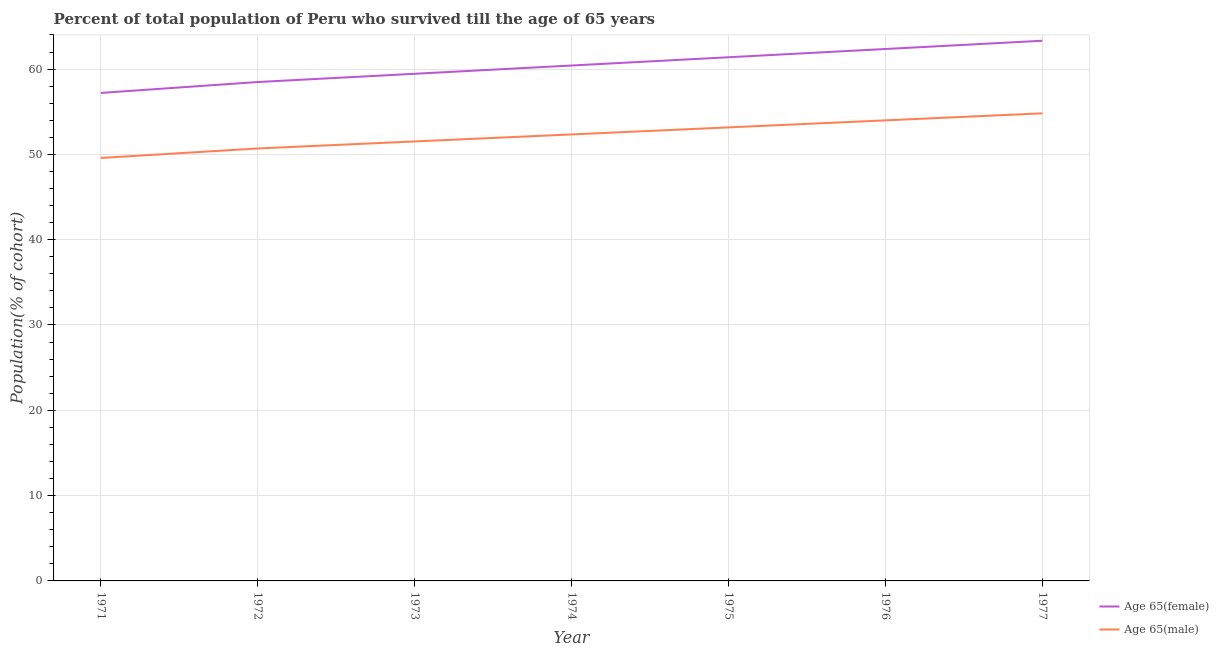What is the percentage of female population who survived till age of 65 in 1974?
Provide a succinct answer. 60.42. Across all years, what is the maximum percentage of male population who survived till age of 65?
Make the answer very short. 54.81. Across all years, what is the minimum percentage of female population who survived till age of 65?
Ensure brevity in your answer.  57.2. In which year was the percentage of male population who survived till age of 65 maximum?
Give a very brief answer. 1977. In which year was the percentage of male population who survived till age of 65 minimum?
Your answer should be very brief. 1971. What is the total percentage of male population who survived till age of 65 in the graph?
Provide a short and direct response. 366.09. What is the difference between the percentage of male population who survived till age of 65 in 1972 and that in 1975?
Ensure brevity in your answer.  -2.47. What is the difference between the percentage of female population who survived till age of 65 in 1976 and the percentage of male population who survived till age of 65 in 1972?
Provide a succinct answer. 11.66. What is the average percentage of female population who survived till age of 65 per year?
Provide a short and direct response. 60.37. In the year 1974, what is the difference between the percentage of female population who survived till age of 65 and percentage of male population who survived till age of 65?
Give a very brief answer. 8.08. What is the ratio of the percentage of male population who survived till age of 65 in 1973 to that in 1976?
Your answer should be compact. 0.95. Is the percentage of male population who survived till age of 65 in 1975 less than that in 1977?
Your response must be concise. Yes. What is the difference between the highest and the second highest percentage of male population who survived till age of 65?
Offer a terse response. 0.82. What is the difference between the highest and the lowest percentage of female population who survived till age of 65?
Keep it short and to the point. 6.12. Is the sum of the percentage of male population who survived till age of 65 in 1975 and 1977 greater than the maximum percentage of female population who survived till age of 65 across all years?
Keep it short and to the point. Yes. Does the percentage of female population who survived till age of 65 monotonically increase over the years?
Give a very brief answer. Yes. What is the difference between two consecutive major ticks on the Y-axis?
Make the answer very short. 10. Are the values on the major ticks of Y-axis written in scientific E-notation?
Offer a terse response. No. Does the graph contain grids?
Keep it short and to the point. Yes. Where does the legend appear in the graph?
Your answer should be very brief. Bottom right. What is the title of the graph?
Keep it short and to the point. Percent of total population of Peru who survived till the age of 65 years. What is the label or title of the X-axis?
Offer a very short reply. Year. What is the label or title of the Y-axis?
Your answer should be very brief. Population(% of cohort). What is the Population(% of cohort) in Age 65(female) in 1971?
Your answer should be compact. 57.2. What is the Population(% of cohort) of Age 65(male) in 1971?
Give a very brief answer. 49.58. What is the Population(% of cohort) of Age 65(female) in 1972?
Your answer should be compact. 58.48. What is the Population(% of cohort) of Age 65(male) in 1972?
Offer a terse response. 50.69. What is the Population(% of cohort) of Age 65(female) in 1973?
Offer a very short reply. 59.45. What is the Population(% of cohort) of Age 65(male) in 1973?
Keep it short and to the point. 51.52. What is the Population(% of cohort) of Age 65(female) in 1974?
Offer a terse response. 60.42. What is the Population(% of cohort) of Age 65(male) in 1974?
Offer a very short reply. 52.34. What is the Population(% of cohort) of Age 65(female) in 1975?
Keep it short and to the point. 61.38. What is the Population(% of cohort) of Age 65(male) in 1975?
Provide a succinct answer. 53.16. What is the Population(% of cohort) in Age 65(female) in 1976?
Offer a terse response. 62.35. What is the Population(% of cohort) in Age 65(male) in 1976?
Your response must be concise. 53.99. What is the Population(% of cohort) of Age 65(female) in 1977?
Keep it short and to the point. 63.32. What is the Population(% of cohort) in Age 65(male) in 1977?
Your answer should be very brief. 54.81. Across all years, what is the maximum Population(% of cohort) in Age 65(female)?
Make the answer very short. 63.32. Across all years, what is the maximum Population(% of cohort) of Age 65(male)?
Provide a short and direct response. 54.81. Across all years, what is the minimum Population(% of cohort) of Age 65(female)?
Offer a very short reply. 57.2. Across all years, what is the minimum Population(% of cohort) in Age 65(male)?
Your answer should be very brief. 49.58. What is the total Population(% of cohort) in Age 65(female) in the graph?
Your answer should be compact. 422.6. What is the total Population(% of cohort) of Age 65(male) in the graph?
Make the answer very short. 366.09. What is the difference between the Population(% of cohort) in Age 65(female) in 1971 and that in 1972?
Your answer should be compact. -1.28. What is the difference between the Population(% of cohort) in Age 65(male) in 1971 and that in 1972?
Give a very brief answer. -1.11. What is the difference between the Population(% of cohort) of Age 65(female) in 1971 and that in 1973?
Keep it short and to the point. -2.25. What is the difference between the Population(% of cohort) in Age 65(male) in 1971 and that in 1973?
Keep it short and to the point. -1.94. What is the difference between the Population(% of cohort) of Age 65(female) in 1971 and that in 1974?
Your answer should be compact. -3.21. What is the difference between the Population(% of cohort) in Age 65(male) in 1971 and that in 1974?
Your answer should be compact. -2.76. What is the difference between the Population(% of cohort) in Age 65(female) in 1971 and that in 1975?
Ensure brevity in your answer.  -4.18. What is the difference between the Population(% of cohort) of Age 65(male) in 1971 and that in 1975?
Keep it short and to the point. -3.58. What is the difference between the Population(% of cohort) of Age 65(female) in 1971 and that in 1976?
Your answer should be compact. -5.15. What is the difference between the Population(% of cohort) of Age 65(male) in 1971 and that in 1976?
Your answer should be very brief. -4.41. What is the difference between the Population(% of cohort) in Age 65(female) in 1971 and that in 1977?
Ensure brevity in your answer.  -6.12. What is the difference between the Population(% of cohort) of Age 65(male) in 1971 and that in 1977?
Ensure brevity in your answer.  -5.23. What is the difference between the Population(% of cohort) in Age 65(female) in 1972 and that in 1973?
Provide a short and direct response. -0.97. What is the difference between the Population(% of cohort) of Age 65(male) in 1972 and that in 1973?
Give a very brief answer. -0.82. What is the difference between the Population(% of cohort) in Age 65(female) in 1972 and that in 1974?
Make the answer very short. -1.94. What is the difference between the Population(% of cohort) of Age 65(male) in 1972 and that in 1974?
Provide a succinct answer. -1.65. What is the difference between the Population(% of cohort) of Age 65(female) in 1972 and that in 1975?
Ensure brevity in your answer.  -2.9. What is the difference between the Population(% of cohort) in Age 65(male) in 1972 and that in 1975?
Your answer should be very brief. -2.47. What is the difference between the Population(% of cohort) of Age 65(female) in 1972 and that in 1976?
Offer a terse response. -3.87. What is the difference between the Population(% of cohort) of Age 65(male) in 1972 and that in 1976?
Offer a very short reply. -3.3. What is the difference between the Population(% of cohort) in Age 65(female) in 1972 and that in 1977?
Your answer should be compact. -4.84. What is the difference between the Population(% of cohort) of Age 65(male) in 1972 and that in 1977?
Your response must be concise. -4.12. What is the difference between the Population(% of cohort) of Age 65(female) in 1973 and that in 1974?
Ensure brevity in your answer.  -0.97. What is the difference between the Population(% of cohort) in Age 65(male) in 1973 and that in 1974?
Your answer should be compact. -0.82. What is the difference between the Population(% of cohort) in Age 65(female) in 1973 and that in 1975?
Your answer should be compact. -1.94. What is the difference between the Population(% of cohort) of Age 65(male) in 1973 and that in 1975?
Your answer should be very brief. -1.65. What is the difference between the Population(% of cohort) in Age 65(female) in 1973 and that in 1976?
Keep it short and to the point. -2.9. What is the difference between the Population(% of cohort) in Age 65(male) in 1973 and that in 1976?
Make the answer very short. -2.47. What is the difference between the Population(% of cohort) in Age 65(female) in 1973 and that in 1977?
Provide a succinct answer. -3.87. What is the difference between the Population(% of cohort) in Age 65(male) in 1973 and that in 1977?
Keep it short and to the point. -3.3. What is the difference between the Population(% of cohort) in Age 65(female) in 1974 and that in 1975?
Your answer should be very brief. -0.97. What is the difference between the Population(% of cohort) in Age 65(male) in 1974 and that in 1975?
Your answer should be compact. -0.82. What is the difference between the Population(% of cohort) in Age 65(female) in 1974 and that in 1976?
Your response must be concise. -1.94. What is the difference between the Population(% of cohort) in Age 65(male) in 1974 and that in 1976?
Make the answer very short. -1.65. What is the difference between the Population(% of cohort) of Age 65(female) in 1974 and that in 1977?
Provide a succinct answer. -2.9. What is the difference between the Population(% of cohort) of Age 65(male) in 1974 and that in 1977?
Make the answer very short. -2.47. What is the difference between the Population(% of cohort) of Age 65(female) in 1975 and that in 1976?
Offer a terse response. -0.97. What is the difference between the Population(% of cohort) in Age 65(male) in 1975 and that in 1976?
Keep it short and to the point. -0.82. What is the difference between the Population(% of cohort) of Age 65(female) in 1975 and that in 1977?
Your answer should be very brief. -1.94. What is the difference between the Population(% of cohort) in Age 65(male) in 1975 and that in 1977?
Your response must be concise. -1.65. What is the difference between the Population(% of cohort) of Age 65(female) in 1976 and that in 1977?
Offer a terse response. -0.97. What is the difference between the Population(% of cohort) of Age 65(male) in 1976 and that in 1977?
Offer a very short reply. -0.82. What is the difference between the Population(% of cohort) of Age 65(female) in 1971 and the Population(% of cohort) of Age 65(male) in 1972?
Provide a succinct answer. 6.51. What is the difference between the Population(% of cohort) of Age 65(female) in 1971 and the Population(% of cohort) of Age 65(male) in 1973?
Ensure brevity in your answer.  5.69. What is the difference between the Population(% of cohort) of Age 65(female) in 1971 and the Population(% of cohort) of Age 65(male) in 1974?
Offer a very short reply. 4.86. What is the difference between the Population(% of cohort) in Age 65(female) in 1971 and the Population(% of cohort) in Age 65(male) in 1975?
Offer a very short reply. 4.04. What is the difference between the Population(% of cohort) in Age 65(female) in 1971 and the Population(% of cohort) in Age 65(male) in 1976?
Keep it short and to the point. 3.22. What is the difference between the Population(% of cohort) in Age 65(female) in 1971 and the Population(% of cohort) in Age 65(male) in 1977?
Provide a short and direct response. 2.39. What is the difference between the Population(% of cohort) of Age 65(female) in 1972 and the Population(% of cohort) of Age 65(male) in 1973?
Provide a succinct answer. 6.96. What is the difference between the Population(% of cohort) in Age 65(female) in 1972 and the Population(% of cohort) in Age 65(male) in 1974?
Provide a succinct answer. 6.14. What is the difference between the Population(% of cohort) in Age 65(female) in 1972 and the Population(% of cohort) in Age 65(male) in 1975?
Make the answer very short. 5.32. What is the difference between the Population(% of cohort) of Age 65(female) in 1972 and the Population(% of cohort) of Age 65(male) in 1976?
Offer a terse response. 4.49. What is the difference between the Population(% of cohort) of Age 65(female) in 1972 and the Population(% of cohort) of Age 65(male) in 1977?
Offer a very short reply. 3.67. What is the difference between the Population(% of cohort) in Age 65(female) in 1973 and the Population(% of cohort) in Age 65(male) in 1974?
Your response must be concise. 7.11. What is the difference between the Population(% of cohort) in Age 65(female) in 1973 and the Population(% of cohort) in Age 65(male) in 1975?
Keep it short and to the point. 6.28. What is the difference between the Population(% of cohort) of Age 65(female) in 1973 and the Population(% of cohort) of Age 65(male) in 1976?
Provide a short and direct response. 5.46. What is the difference between the Population(% of cohort) of Age 65(female) in 1973 and the Population(% of cohort) of Age 65(male) in 1977?
Provide a short and direct response. 4.64. What is the difference between the Population(% of cohort) in Age 65(female) in 1974 and the Population(% of cohort) in Age 65(male) in 1975?
Provide a succinct answer. 7.25. What is the difference between the Population(% of cohort) of Age 65(female) in 1974 and the Population(% of cohort) of Age 65(male) in 1976?
Ensure brevity in your answer.  6.43. What is the difference between the Population(% of cohort) in Age 65(female) in 1974 and the Population(% of cohort) in Age 65(male) in 1977?
Make the answer very short. 5.6. What is the difference between the Population(% of cohort) of Age 65(female) in 1975 and the Population(% of cohort) of Age 65(male) in 1976?
Offer a very short reply. 7.4. What is the difference between the Population(% of cohort) in Age 65(female) in 1975 and the Population(% of cohort) in Age 65(male) in 1977?
Offer a very short reply. 6.57. What is the difference between the Population(% of cohort) of Age 65(female) in 1976 and the Population(% of cohort) of Age 65(male) in 1977?
Ensure brevity in your answer.  7.54. What is the average Population(% of cohort) in Age 65(female) per year?
Your response must be concise. 60.37. What is the average Population(% of cohort) of Age 65(male) per year?
Ensure brevity in your answer.  52.3. In the year 1971, what is the difference between the Population(% of cohort) of Age 65(female) and Population(% of cohort) of Age 65(male)?
Your answer should be very brief. 7.62. In the year 1972, what is the difference between the Population(% of cohort) in Age 65(female) and Population(% of cohort) in Age 65(male)?
Your response must be concise. 7.79. In the year 1973, what is the difference between the Population(% of cohort) in Age 65(female) and Population(% of cohort) in Age 65(male)?
Provide a short and direct response. 7.93. In the year 1974, what is the difference between the Population(% of cohort) of Age 65(female) and Population(% of cohort) of Age 65(male)?
Offer a terse response. 8.08. In the year 1975, what is the difference between the Population(% of cohort) in Age 65(female) and Population(% of cohort) in Age 65(male)?
Your answer should be compact. 8.22. In the year 1976, what is the difference between the Population(% of cohort) of Age 65(female) and Population(% of cohort) of Age 65(male)?
Provide a short and direct response. 8.37. In the year 1977, what is the difference between the Population(% of cohort) in Age 65(female) and Population(% of cohort) in Age 65(male)?
Your answer should be very brief. 8.51. What is the ratio of the Population(% of cohort) in Age 65(female) in 1971 to that in 1972?
Your response must be concise. 0.98. What is the ratio of the Population(% of cohort) of Age 65(male) in 1971 to that in 1972?
Your response must be concise. 0.98. What is the ratio of the Population(% of cohort) in Age 65(female) in 1971 to that in 1973?
Offer a very short reply. 0.96. What is the ratio of the Population(% of cohort) in Age 65(male) in 1971 to that in 1973?
Keep it short and to the point. 0.96. What is the ratio of the Population(% of cohort) in Age 65(female) in 1971 to that in 1974?
Make the answer very short. 0.95. What is the ratio of the Population(% of cohort) of Age 65(male) in 1971 to that in 1974?
Your response must be concise. 0.95. What is the ratio of the Population(% of cohort) of Age 65(female) in 1971 to that in 1975?
Give a very brief answer. 0.93. What is the ratio of the Population(% of cohort) in Age 65(male) in 1971 to that in 1975?
Provide a succinct answer. 0.93. What is the ratio of the Population(% of cohort) in Age 65(female) in 1971 to that in 1976?
Your answer should be compact. 0.92. What is the ratio of the Population(% of cohort) of Age 65(male) in 1971 to that in 1976?
Your answer should be very brief. 0.92. What is the ratio of the Population(% of cohort) of Age 65(female) in 1971 to that in 1977?
Make the answer very short. 0.9. What is the ratio of the Population(% of cohort) in Age 65(male) in 1971 to that in 1977?
Your answer should be compact. 0.9. What is the ratio of the Population(% of cohort) of Age 65(female) in 1972 to that in 1973?
Your answer should be compact. 0.98. What is the ratio of the Population(% of cohort) of Age 65(female) in 1972 to that in 1974?
Your answer should be compact. 0.97. What is the ratio of the Population(% of cohort) of Age 65(male) in 1972 to that in 1974?
Offer a terse response. 0.97. What is the ratio of the Population(% of cohort) in Age 65(female) in 1972 to that in 1975?
Your response must be concise. 0.95. What is the ratio of the Population(% of cohort) of Age 65(male) in 1972 to that in 1975?
Your answer should be compact. 0.95. What is the ratio of the Population(% of cohort) of Age 65(female) in 1972 to that in 1976?
Give a very brief answer. 0.94. What is the ratio of the Population(% of cohort) in Age 65(male) in 1972 to that in 1976?
Give a very brief answer. 0.94. What is the ratio of the Population(% of cohort) of Age 65(female) in 1972 to that in 1977?
Offer a terse response. 0.92. What is the ratio of the Population(% of cohort) in Age 65(male) in 1972 to that in 1977?
Your answer should be compact. 0.92. What is the ratio of the Population(% of cohort) in Age 65(female) in 1973 to that in 1974?
Your answer should be compact. 0.98. What is the ratio of the Population(% of cohort) in Age 65(male) in 1973 to that in 1974?
Keep it short and to the point. 0.98. What is the ratio of the Population(% of cohort) in Age 65(female) in 1973 to that in 1975?
Ensure brevity in your answer.  0.97. What is the ratio of the Population(% of cohort) of Age 65(male) in 1973 to that in 1975?
Offer a terse response. 0.97. What is the ratio of the Population(% of cohort) in Age 65(female) in 1973 to that in 1976?
Give a very brief answer. 0.95. What is the ratio of the Population(% of cohort) of Age 65(male) in 1973 to that in 1976?
Offer a very short reply. 0.95. What is the ratio of the Population(% of cohort) of Age 65(female) in 1973 to that in 1977?
Offer a terse response. 0.94. What is the ratio of the Population(% of cohort) of Age 65(male) in 1973 to that in 1977?
Your answer should be very brief. 0.94. What is the ratio of the Population(% of cohort) of Age 65(female) in 1974 to that in 1975?
Keep it short and to the point. 0.98. What is the ratio of the Population(% of cohort) in Age 65(male) in 1974 to that in 1975?
Give a very brief answer. 0.98. What is the ratio of the Population(% of cohort) of Age 65(female) in 1974 to that in 1976?
Offer a terse response. 0.97. What is the ratio of the Population(% of cohort) of Age 65(male) in 1974 to that in 1976?
Provide a short and direct response. 0.97. What is the ratio of the Population(% of cohort) in Age 65(female) in 1974 to that in 1977?
Provide a short and direct response. 0.95. What is the ratio of the Population(% of cohort) in Age 65(male) in 1974 to that in 1977?
Keep it short and to the point. 0.95. What is the ratio of the Population(% of cohort) of Age 65(female) in 1975 to that in 1976?
Offer a terse response. 0.98. What is the ratio of the Population(% of cohort) in Age 65(male) in 1975 to that in 1976?
Provide a short and direct response. 0.98. What is the ratio of the Population(% of cohort) in Age 65(female) in 1975 to that in 1977?
Keep it short and to the point. 0.97. What is the ratio of the Population(% of cohort) of Age 65(male) in 1975 to that in 1977?
Offer a terse response. 0.97. What is the ratio of the Population(% of cohort) of Age 65(female) in 1976 to that in 1977?
Your answer should be very brief. 0.98. What is the difference between the highest and the second highest Population(% of cohort) in Age 65(female)?
Provide a short and direct response. 0.97. What is the difference between the highest and the second highest Population(% of cohort) in Age 65(male)?
Provide a short and direct response. 0.82. What is the difference between the highest and the lowest Population(% of cohort) in Age 65(female)?
Your response must be concise. 6.12. What is the difference between the highest and the lowest Population(% of cohort) of Age 65(male)?
Ensure brevity in your answer.  5.23. 